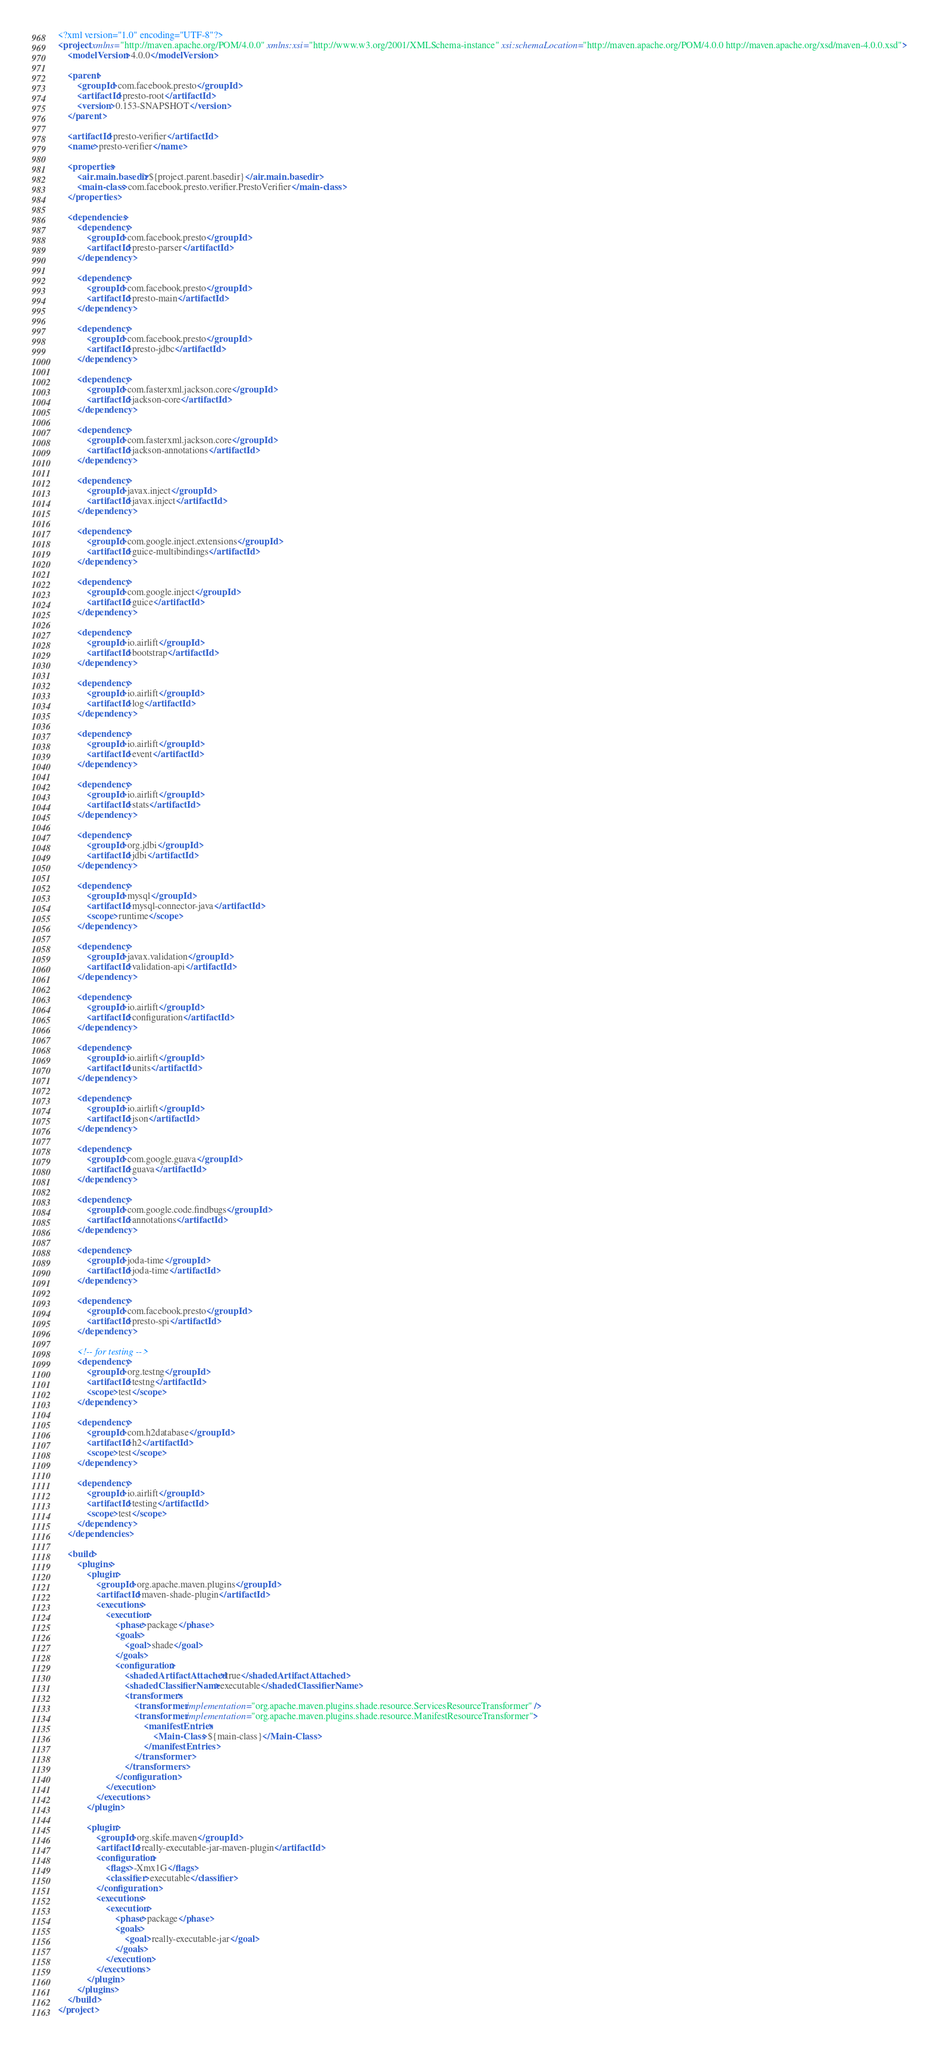Convert code to text. <code><loc_0><loc_0><loc_500><loc_500><_XML_><?xml version="1.0" encoding="UTF-8"?>
<project xmlns="http://maven.apache.org/POM/4.0.0" xmlns:xsi="http://www.w3.org/2001/XMLSchema-instance" xsi:schemaLocation="http://maven.apache.org/POM/4.0.0 http://maven.apache.org/xsd/maven-4.0.0.xsd">
    <modelVersion>4.0.0</modelVersion>

    <parent>
        <groupId>com.facebook.presto</groupId>
        <artifactId>presto-root</artifactId>
        <version>0.153-SNAPSHOT</version>
    </parent>

    <artifactId>presto-verifier</artifactId>
    <name>presto-verifier</name>

    <properties>
        <air.main.basedir>${project.parent.basedir}</air.main.basedir>
        <main-class>com.facebook.presto.verifier.PrestoVerifier</main-class>
    </properties>

    <dependencies>
        <dependency>
            <groupId>com.facebook.presto</groupId>
            <artifactId>presto-parser</artifactId>
        </dependency>

        <dependency>
            <groupId>com.facebook.presto</groupId>
            <artifactId>presto-main</artifactId>
        </dependency>

        <dependency>
            <groupId>com.facebook.presto</groupId>
            <artifactId>presto-jdbc</artifactId>
        </dependency>

        <dependency>
            <groupId>com.fasterxml.jackson.core</groupId>
            <artifactId>jackson-core</artifactId>
        </dependency>

        <dependency>
            <groupId>com.fasterxml.jackson.core</groupId>
            <artifactId>jackson-annotations</artifactId>
        </dependency>

        <dependency>
            <groupId>javax.inject</groupId>
            <artifactId>javax.inject</artifactId>
        </dependency>

        <dependency>
            <groupId>com.google.inject.extensions</groupId>
            <artifactId>guice-multibindings</artifactId>
        </dependency>

        <dependency>
            <groupId>com.google.inject</groupId>
            <artifactId>guice</artifactId>
        </dependency>

        <dependency>
            <groupId>io.airlift</groupId>
            <artifactId>bootstrap</artifactId>
        </dependency>

        <dependency>
            <groupId>io.airlift</groupId>
            <artifactId>log</artifactId>
        </dependency>

        <dependency>
            <groupId>io.airlift</groupId>
            <artifactId>event</artifactId>
        </dependency>

        <dependency>
            <groupId>io.airlift</groupId>
            <artifactId>stats</artifactId>
        </dependency>

        <dependency>
            <groupId>org.jdbi</groupId>
            <artifactId>jdbi</artifactId>
        </dependency>

        <dependency>
            <groupId>mysql</groupId>
            <artifactId>mysql-connector-java</artifactId>
            <scope>runtime</scope>
        </dependency>

        <dependency>
            <groupId>javax.validation</groupId>
            <artifactId>validation-api</artifactId>
        </dependency>

        <dependency>
            <groupId>io.airlift</groupId>
            <artifactId>configuration</artifactId>
        </dependency>

        <dependency>
            <groupId>io.airlift</groupId>
            <artifactId>units</artifactId>
        </dependency>

        <dependency>
            <groupId>io.airlift</groupId>
            <artifactId>json</artifactId>
        </dependency>

        <dependency>
            <groupId>com.google.guava</groupId>
            <artifactId>guava</artifactId>
        </dependency>

        <dependency>
            <groupId>com.google.code.findbugs</groupId>
            <artifactId>annotations</artifactId>
        </dependency>

        <dependency>
            <groupId>joda-time</groupId>
            <artifactId>joda-time</artifactId>
        </dependency>

        <dependency>
            <groupId>com.facebook.presto</groupId>
            <artifactId>presto-spi</artifactId>
        </dependency>

        <!-- for testing -->
        <dependency>
            <groupId>org.testng</groupId>
            <artifactId>testng</artifactId>
            <scope>test</scope>
        </dependency>

        <dependency>
            <groupId>com.h2database</groupId>
            <artifactId>h2</artifactId>
            <scope>test</scope>
        </dependency>

        <dependency>
            <groupId>io.airlift</groupId>
            <artifactId>testing</artifactId>
            <scope>test</scope>
        </dependency>
    </dependencies>

    <build>
        <plugins>
            <plugin>
                <groupId>org.apache.maven.plugins</groupId>
                <artifactId>maven-shade-plugin</artifactId>
                <executions>
                    <execution>
                        <phase>package</phase>
                        <goals>
                            <goal>shade</goal>
                        </goals>
                        <configuration>
                            <shadedArtifactAttached>true</shadedArtifactAttached>
                            <shadedClassifierName>executable</shadedClassifierName>
                            <transformers>
                                <transformer implementation="org.apache.maven.plugins.shade.resource.ServicesResourceTransformer" />
                                <transformer implementation="org.apache.maven.plugins.shade.resource.ManifestResourceTransformer">
                                    <manifestEntries>
                                        <Main-Class>${main-class}</Main-Class>
                                    </manifestEntries>
                                </transformer>
                            </transformers>
                        </configuration>
                    </execution>
                </executions>
            </plugin>

            <plugin>
                <groupId>org.skife.maven</groupId>
                <artifactId>really-executable-jar-maven-plugin</artifactId>
                <configuration>
                    <flags>-Xmx1G</flags>
                    <classifier>executable</classifier>
                </configuration>
                <executions>
                    <execution>
                        <phase>package</phase>
                        <goals>
                            <goal>really-executable-jar</goal>
                        </goals>
                    </execution>
                </executions>
            </plugin>
        </plugins>
    </build>
</project>
</code> 